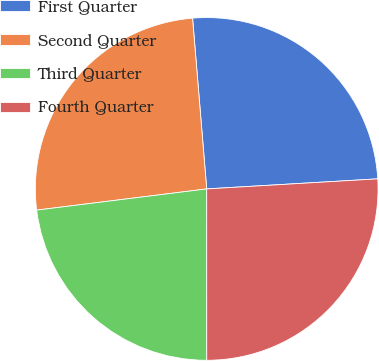Convert chart to OTSL. <chart><loc_0><loc_0><loc_500><loc_500><pie_chart><fcel>First Quarter<fcel>Second Quarter<fcel>Third Quarter<fcel>Fourth Quarter<nl><fcel>25.38%<fcel>25.66%<fcel>23.03%<fcel>25.93%<nl></chart> 